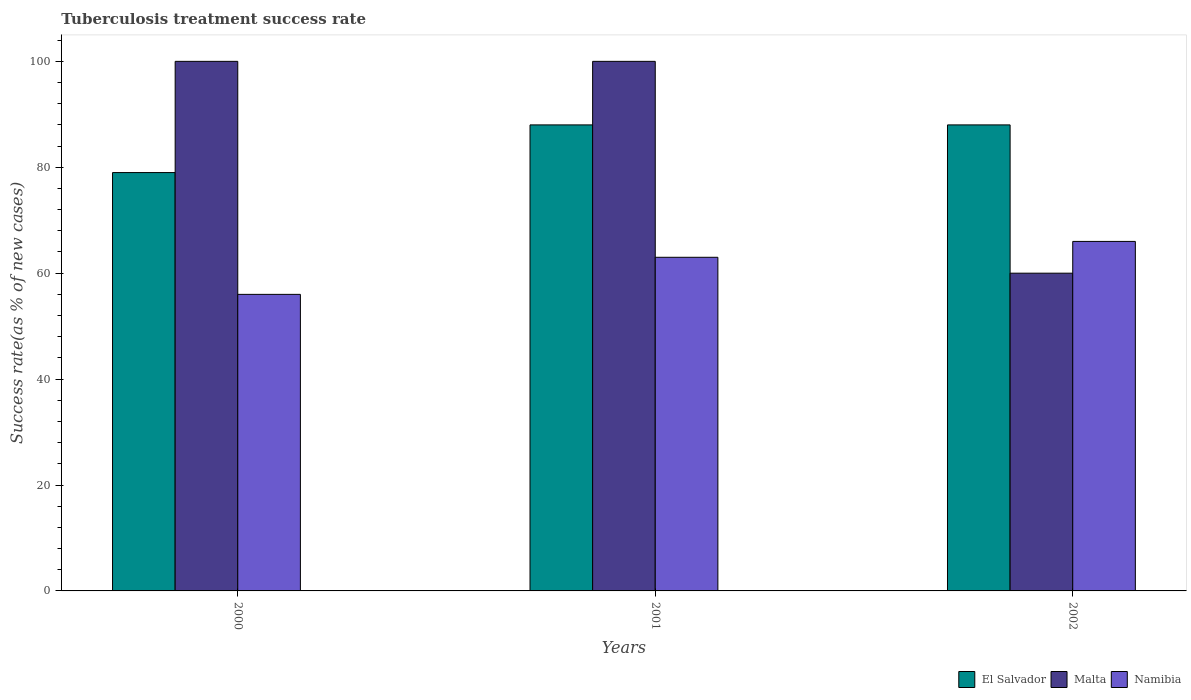How many groups of bars are there?
Keep it short and to the point. 3. Are the number of bars per tick equal to the number of legend labels?
Offer a very short reply. Yes. How many bars are there on the 3rd tick from the left?
Offer a terse response. 3. What is the label of the 1st group of bars from the left?
Your answer should be compact. 2000. In how many cases, is the number of bars for a given year not equal to the number of legend labels?
Offer a terse response. 0. What is the tuberculosis treatment success rate in Malta in 2001?
Offer a very short reply. 100. Across all years, what is the minimum tuberculosis treatment success rate in Namibia?
Your response must be concise. 56. What is the total tuberculosis treatment success rate in Malta in the graph?
Your answer should be compact. 260. What is the difference between the tuberculosis treatment success rate in Malta in 2000 and that in 2002?
Your answer should be very brief. 40. What is the difference between the tuberculosis treatment success rate in Malta in 2000 and the tuberculosis treatment success rate in El Salvador in 2002?
Offer a terse response. 12. In how many years, is the tuberculosis treatment success rate in Namibia greater than 56 %?
Your answer should be compact. 2. What is the ratio of the tuberculosis treatment success rate in Malta in 2001 to that in 2002?
Your response must be concise. 1.67. Is the tuberculosis treatment success rate in Malta in 2000 less than that in 2001?
Ensure brevity in your answer.  No. Is the difference between the tuberculosis treatment success rate in Malta in 2000 and 2002 greater than the difference between the tuberculosis treatment success rate in El Salvador in 2000 and 2002?
Your answer should be compact. Yes. What is the difference between the highest and the lowest tuberculosis treatment success rate in El Salvador?
Provide a succinct answer. 9. What does the 3rd bar from the left in 2000 represents?
Ensure brevity in your answer.  Namibia. What does the 3rd bar from the right in 2000 represents?
Keep it short and to the point. El Salvador. Is it the case that in every year, the sum of the tuberculosis treatment success rate in Namibia and tuberculosis treatment success rate in El Salvador is greater than the tuberculosis treatment success rate in Malta?
Keep it short and to the point. Yes. How many bars are there?
Provide a succinct answer. 9. Are all the bars in the graph horizontal?
Your answer should be compact. No. Does the graph contain any zero values?
Offer a very short reply. No. Does the graph contain grids?
Your answer should be compact. No. How many legend labels are there?
Your answer should be very brief. 3. What is the title of the graph?
Offer a very short reply. Tuberculosis treatment success rate. Does "China" appear as one of the legend labels in the graph?
Your answer should be very brief. No. What is the label or title of the X-axis?
Offer a very short reply. Years. What is the label or title of the Y-axis?
Provide a succinct answer. Success rate(as % of new cases). What is the Success rate(as % of new cases) of El Salvador in 2000?
Make the answer very short. 79. What is the Success rate(as % of new cases) in Malta in 2000?
Keep it short and to the point. 100. What is the Success rate(as % of new cases) of Namibia in 2000?
Provide a succinct answer. 56. What is the Success rate(as % of new cases) of Namibia in 2001?
Ensure brevity in your answer.  63. What is the Success rate(as % of new cases) in El Salvador in 2002?
Offer a very short reply. 88. What is the Success rate(as % of new cases) in Malta in 2002?
Your response must be concise. 60. What is the Success rate(as % of new cases) in Namibia in 2002?
Your answer should be very brief. 66. Across all years, what is the maximum Success rate(as % of new cases) of Malta?
Your response must be concise. 100. Across all years, what is the maximum Success rate(as % of new cases) of Namibia?
Give a very brief answer. 66. Across all years, what is the minimum Success rate(as % of new cases) in El Salvador?
Offer a terse response. 79. Across all years, what is the minimum Success rate(as % of new cases) in Malta?
Make the answer very short. 60. Across all years, what is the minimum Success rate(as % of new cases) in Namibia?
Your response must be concise. 56. What is the total Success rate(as % of new cases) of El Salvador in the graph?
Provide a short and direct response. 255. What is the total Success rate(as % of new cases) of Malta in the graph?
Give a very brief answer. 260. What is the total Success rate(as % of new cases) of Namibia in the graph?
Provide a short and direct response. 185. What is the difference between the Success rate(as % of new cases) of Malta in 2000 and that in 2001?
Keep it short and to the point. 0. What is the difference between the Success rate(as % of new cases) in Namibia in 2000 and that in 2001?
Give a very brief answer. -7. What is the difference between the Success rate(as % of new cases) in El Salvador in 2000 and that in 2002?
Provide a succinct answer. -9. What is the difference between the Success rate(as % of new cases) in Malta in 2000 and that in 2002?
Your response must be concise. 40. What is the difference between the Success rate(as % of new cases) in El Salvador in 2000 and the Success rate(as % of new cases) in Namibia in 2001?
Make the answer very short. 16. What is the difference between the Success rate(as % of new cases) of Malta in 2000 and the Success rate(as % of new cases) of Namibia in 2001?
Provide a succinct answer. 37. What is the difference between the Success rate(as % of new cases) in El Salvador in 2000 and the Success rate(as % of new cases) in Malta in 2002?
Your answer should be compact. 19. What is the difference between the Success rate(as % of new cases) of El Salvador in 2000 and the Success rate(as % of new cases) of Namibia in 2002?
Offer a terse response. 13. What is the difference between the Success rate(as % of new cases) of El Salvador in 2001 and the Success rate(as % of new cases) of Malta in 2002?
Keep it short and to the point. 28. What is the difference between the Success rate(as % of new cases) in El Salvador in 2001 and the Success rate(as % of new cases) in Namibia in 2002?
Make the answer very short. 22. What is the average Success rate(as % of new cases) in Malta per year?
Keep it short and to the point. 86.67. What is the average Success rate(as % of new cases) in Namibia per year?
Give a very brief answer. 61.67. In the year 2000, what is the difference between the Success rate(as % of new cases) of Malta and Success rate(as % of new cases) of Namibia?
Ensure brevity in your answer.  44. In the year 2001, what is the difference between the Success rate(as % of new cases) in El Salvador and Success rate(as % of new cases) in Namibia?
Make the answer very short. 25. In the year 2001, what is the difference between the Success rate(as % of new cases) in Malta and Success rate(as % of new cases) in Namibia?
Provide a succinct answer. 37. In the year 2002, what is the difference between the Success rate(as % of new cases) of El Salvador and Success rate(as % of new cases) of Malta?
Provide a succinct answer. 28. In the year 2002, what is the difference between the Success rate(as % of new cases) of Malta and Success rate(as % of new cases) of Namibia?
Offer a terse response. -6. What is the ratio of the Success rate(as % of new cases) of El Salvador in 2000 to that in 2001?
Give a very brief answer. 0.9. What is the ratio of the Success rate(as % of new cases) in Namibia in 2000 to that in 2001?
Your response must be concise. 0.89. What is the ratio of the Success rate(as % of new cases) in El Salvador in 2000 to that in 2002?
Provide a short and direct response. 0.9. What is the ratio of the Success rate(as % of new cases) in Namibia in 2000 to that in 2002?
Offer a terse response. 0.85. What is the ratio of the Success rate(as % of new cases) of El Salvador in 2001 to that in 2002?
Make the answer very short. 1. What is the ratio of the Success rate(as % of new cases) of Malta in 2001 to that in 2002?
Ensure brevity in your answer.  1.67. What is the ratio of the Success rate(as % of new cases) of Namibia in 2001 to that in 2002?
Your answer should be very brief. 0.95. What is the difference between the highest and the second highest Success rate(as % of new cases) of Malta?
Your answer should be compact. 0. What is the difference between the highest and the second highest Success rate(as % of new cases) in Namibia?
Provide a succinct answer. 3. What is the difference between the highest and the lowest Success rate(as % of new cases) in Namibia?
Your response must be concise. 10. 